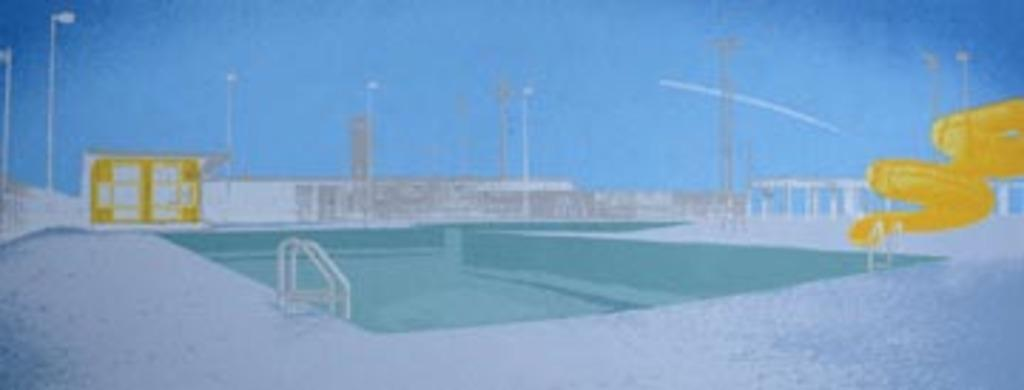What is the main subject of the image? There is a painting in the image. What can be seen in the background of the painting? There are buildings in the background of the image. What is located on the right side of the image? There is an object on the right side of the image. What type of lighting is present in the image? There are street lights in the image. What is visible at the top of the image? The sky is visible at the top of the image. Is there any water feature in the image? Yes, there is a swimming pool in the image. How does the group of people in the image react to the sudden impulse to jump into the swimming pool? There are no people present in the image, so it is not possible to determine their reaction to any impulse. 